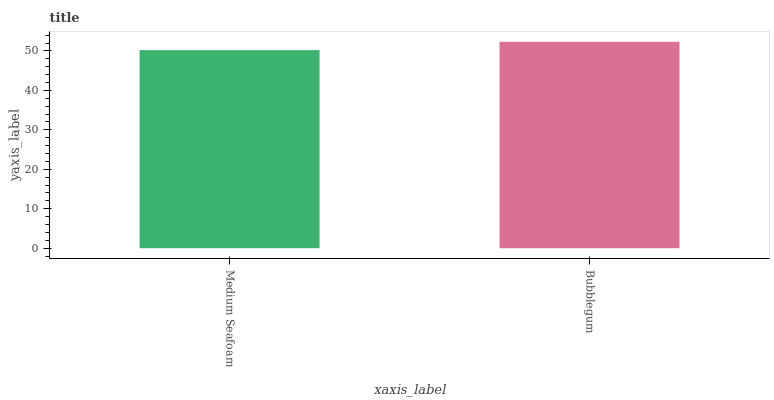Is Medium Seafoam the minimum?
Answer yes or no. Yes. Is Bubblegum the maximum?
Answer yes or no. Yes. Is Bubblegum the minimum?
Answer yes or no. No. Is Bubblegum greater than Medium Seafoam?
Answer yes or no. Yes. Is Medium Seafoam less than Bubblegum?
Answer yes or no. Yes. Is Medium Seafoam greater than Bubblegum?
Answer yes or no. No. Is Bubblegum less than Medium Seafoam?
Answer yes or no. No. Is Bubblegum the high median?
Answer yes or no. Yes. Is Medium Seafoam the low median?
Answer yes or no. Yes. Is Medium Seafoam the high median?
Answer yes or no. No. Is Bubblegum the low median?
Answer yes or no. No. 